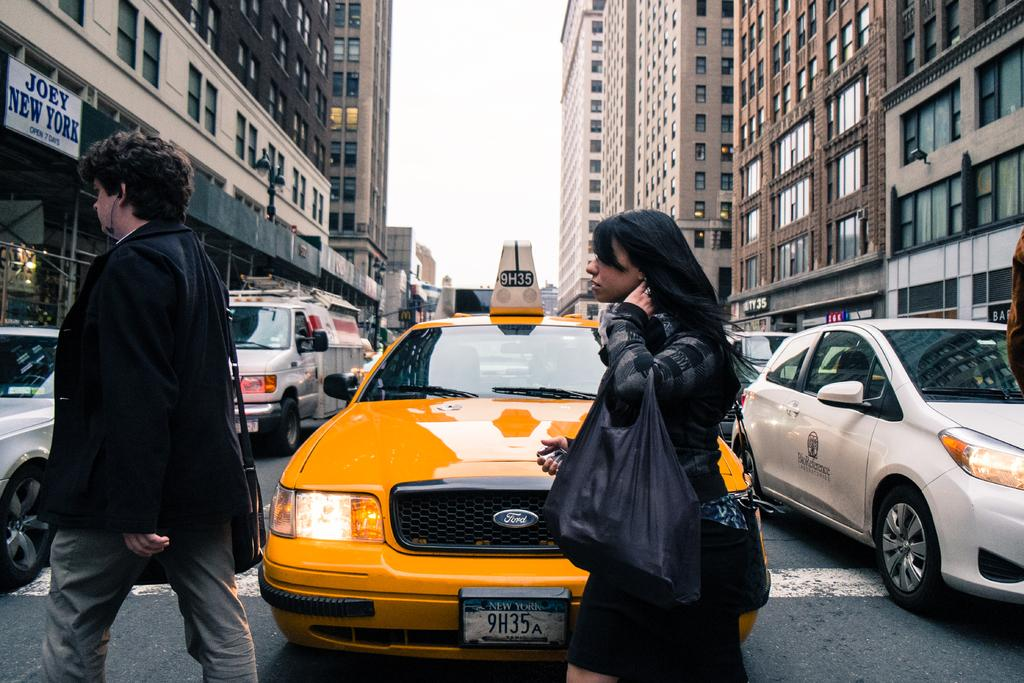<image>
Summarize the visual content of the image. A taxi cab has a New York license plate number of 9H35A. 